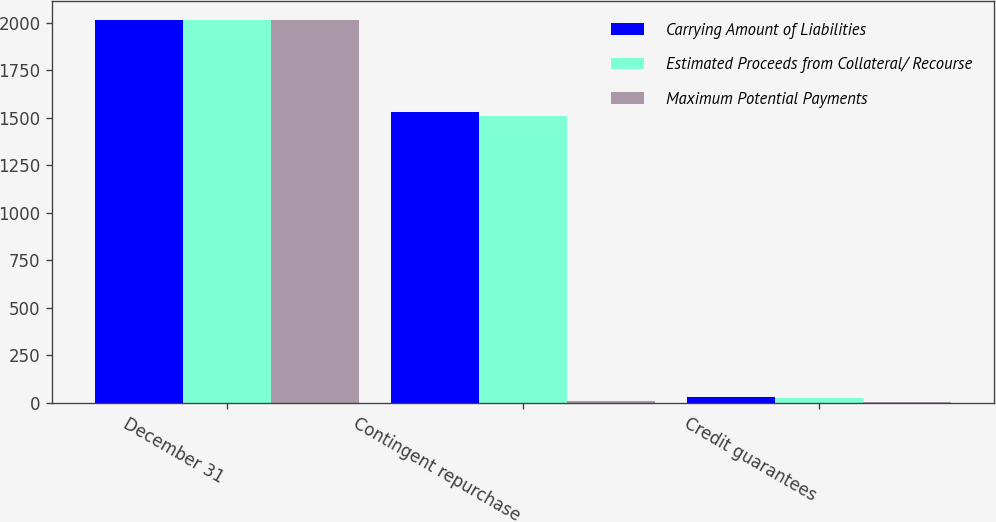<chart> <loc_0><loc_0><loc_500><loc_500><stacked_bar_chart><ecel><fcel>December 31<fcel>Contingent repurchase<fcel>Credit guarantees<nl><fcel>Carrying Amount of Liabilities<fcel>2015<fcel>1529<fcel>30<nl><fcel>Estimated Proceeds from Collateral/ Recourse<fcel>2015<fcel>1510<fcel>27<nl><fcel>Maximum Potential Payments<fcel>2015<fcel>7<fcel>2<nl></chart> 